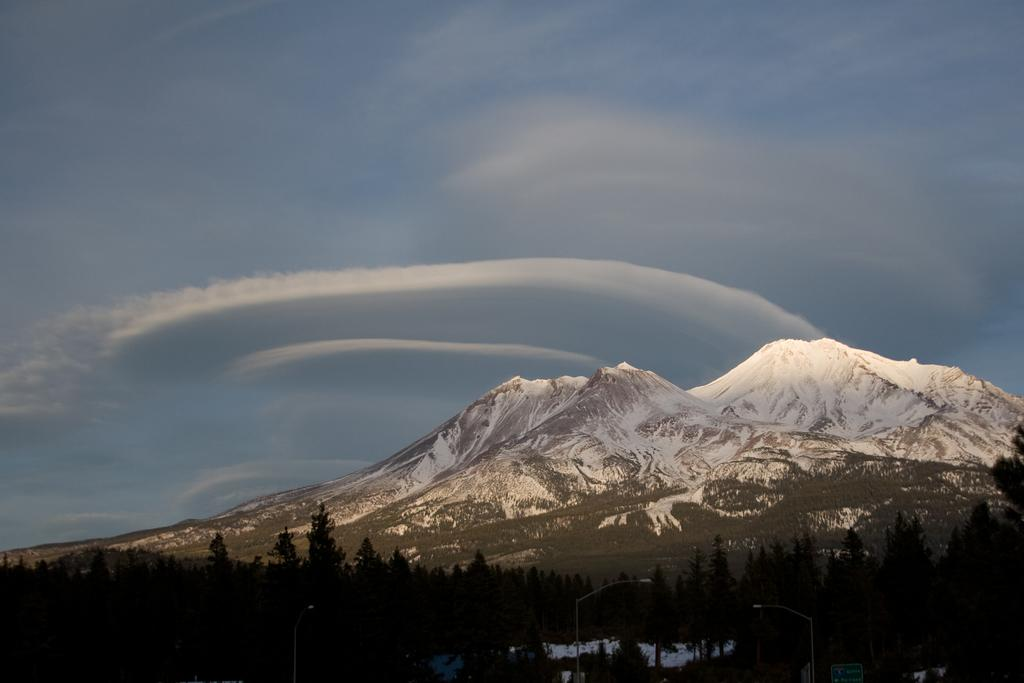What can be seen in the sky in the image? The sky with clouds is visible in the image. What type of natural landform is present in the image? There are mountains in the image. What type of vegetation is present in the image? Trees are present in the image. What type of man-made structures are visible in the image? Street poles and street lights are present in the image. What type of signage is visible in the image? A sign board is visible in the image. Where is the playground located in the image? There is no playground present in the image. What type of stick is being used by the trees in the image? Trees do not use sticks; they are plants with roots, trunks, and branches. 